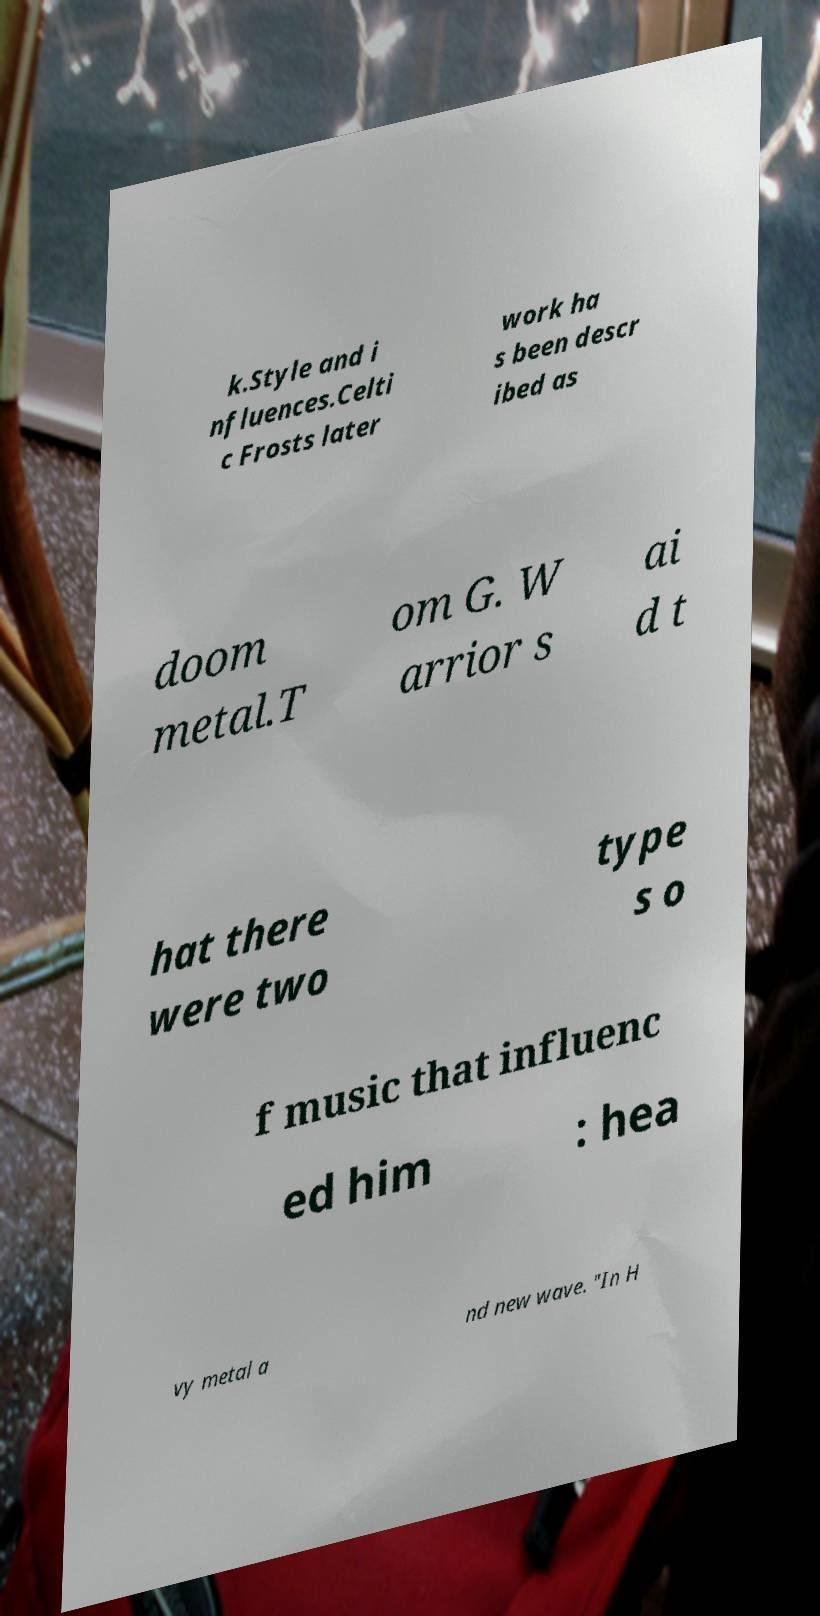There's text embedded in this image that I need extracted. Can you transcribe it verbatim? k.Style and i nfluences.Celti c Frosts later work ha s been descr ibed as doom metal.T om G. W arrior s ai d t hat there were two type s o f music that influenc ed him : hea vy metal a nd new wave. "In H 